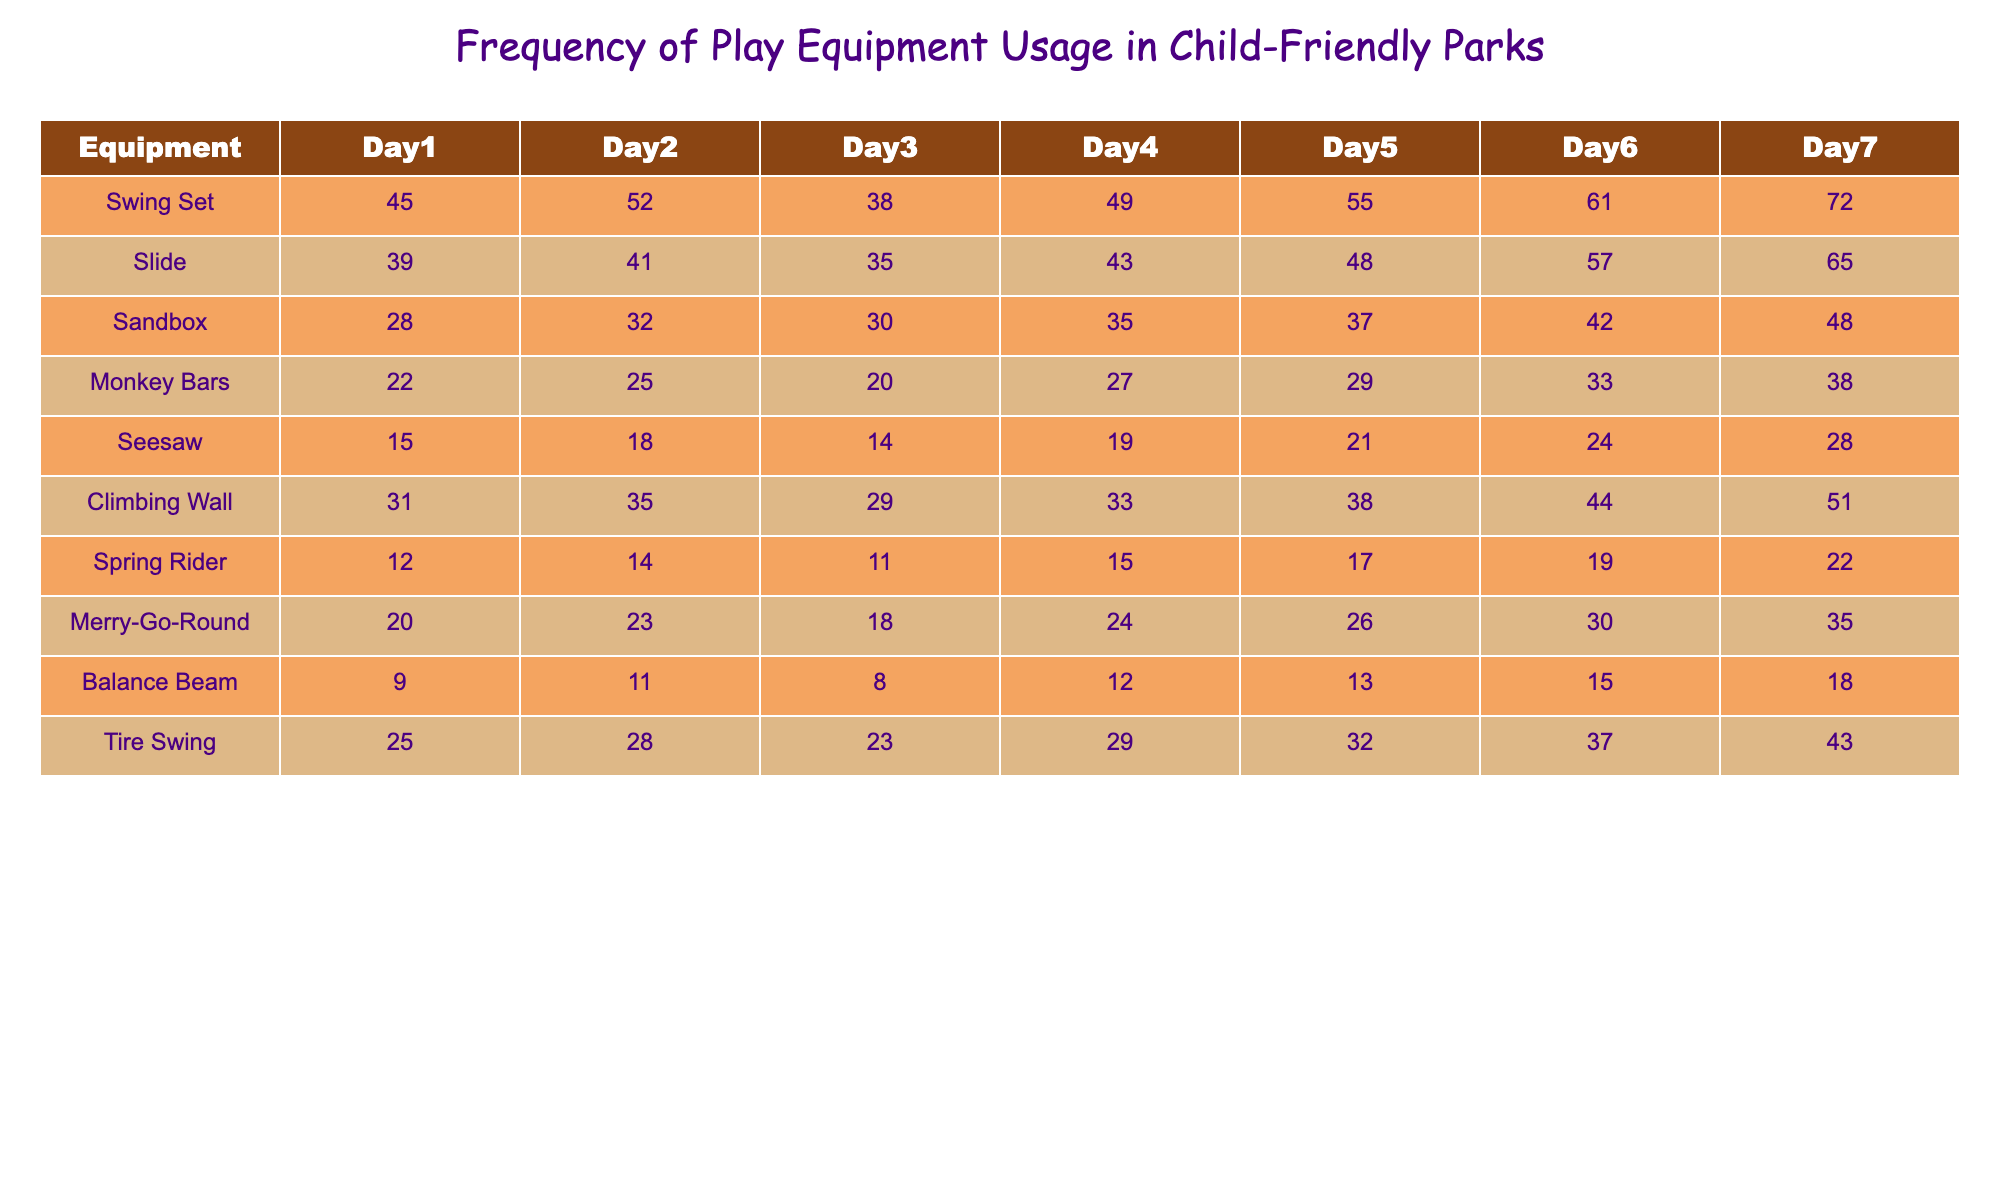What is the maximum usage of the Slide? Looking at the row for the Slide, the highest frequency recorded is 65 on Day 7.
Answer: 65 What was the average usage of the Swing Set over the 7 days? Adding up the values for the Swing Set (45 + 52 + 38 + 49 + 55 + 61 + 72 = 372) gives a total frequency of 372. To find the average, divide by 7, resulting in 372/7 = 53.14.
Answer: 53.14 Did the usage of the Merry-Go-Round increase every day? Comparing the values from Day 1 to Day 7, the usage is 20, 23, 18, 24, 26, 30, and 35. The second value (23) is greater than the first (20), but the third value (18) is less than the second (23), indicating there was a decrease. Therefore, the usage did not consistently increase.
Answer: No How many more times was the Swing Set used than the Climbing Wall on Day 5? On Day 5, the Swing Set usage is 55, and the Climbing Wall usage is 38. The difference is 55 - 38 = 17, indicating that the Swing Set was used 17 more times.
Answer: 17 What is the total frequency of usage for the Sandbox and Merry-Go-Round combined over the week? The Sandbox usage totals are (28 + 32 + 30 + 35 + 37 + 42 + 48 = 252), and the Merry-Go-Round totals are (20 + 23 + 18 + 24 + 26 + 30 + 35 = 176). Adding these two totals gives 252 + 176 = 428.
Answer: 428 Which play equipment had the lowest overall usage, and what was that total? The equipment with the lowest overall usage is the Balance Beam, with totals of (9 + 11 + 8 + 12 + 13 + 15 + 18 = 86).
Answer: Balance Beam, 86 What is the percentage increase in usage of the Tire Swing from Day 1 to Day 7? For the Tire Swing, Day 1 usage is 25, and Day 7 is 43. The increase is 43 - 25 = 18. To calculate the percentage increase, divide the increase by the original value (18/25) and multiply by 100, resulting in 72%.
Answer: 72% On which day was the usage of the Climbing Wall the highest, and what was the number? The Climbing Wall usage shows improvement from Day 1 to Day 7 with values of 31, 35, 29, 33, 38, 44, and 51. The highest usage was on Day 7 at 51.
Answer: Day 7, 51 How many total children used the Seesaw over the week? The total usage of the Seesaw for the week is 15 + 18 + 14 + 19 + 21 + 24 + 28 = 119.
Answer: 119 Is there any day when the usage of the Spring Rider was less than 15? The usage values for the Spring Rider are 12, 14, 11, 15, 17, 19, and 22. The values for Day 1 (12), Day 2 (14), and Day 3 (11) are all less than 15. Therefore, there were days with less than 15 usage.
Answer: Yes 